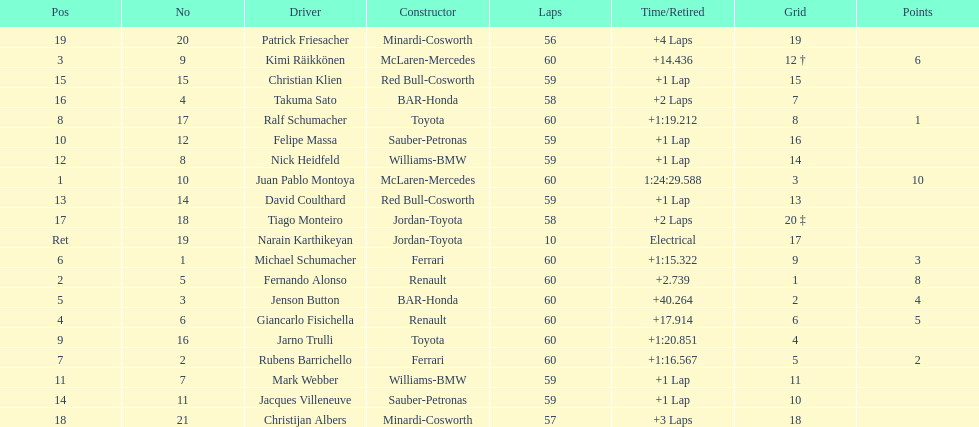Would you be able to parse every entry in this table? {'header': ['Pos', 'No', 'Driver', 'Constructor', 'Laps', 'Time/Retired', 'Grid', 'Points'], 'rows': [['19', '20', 'Patrick Friesacher', 'Minardi-Cosworth', '56', '+4 Laps', '19', ''], ['3', '9', 'Kimi Räikkönen', 'McLaren-Mercedes', '60', '+14.436', '12 †', '6'], ['15', '15', 'Christian Klien', 'Red Bull-Cosworth', '59', '+1 Lap', '15', ''], ['16', '4', 'Takuma Sato', 'BAR-Honda', '58', '+2 Laps', '7', ''], ['8', '17', 'Ralf Schumacher', 'Toyota', '60', '+1:19.212', '8', '1'], ['10', '12', 'Felipe Massa', 'Sauber-Petronas', '59', '+1 Lap', '16', ''], ['12', '8', 'Nick Heidfeld', 'Williams-BMW', '59', '+1 Lap', '14', ''], ['1', '10', 'Juan Pablo Montoya', 'McLaren-Mercedes', '60', '1:24:29.588', '3', '10'], ['13', '14', 'David Coulthard', 'Red Bull-Cosworth', '59', '+1 Lap', '13', ''], ['17', '18', 'Tiago Monteiro', 'Jordan-Toyota', '58', '+2 Laps', '20 ‡', ''], ['Ret', '19', 'Narain Karthikeyan', 'Jordan-Toyota', '10', 'Electrical', '17', ''], ['6', '1', 'Michael Schumacher', 'Ferrari', '60', '+1:15.322', '9', '3'], ['2', '5', 'Fernando Alonso', 'Renault', '60', '+2.739', '1', '8'], ['5', '3', 'Jenson Button', 'BAR-Honda', '60', '+40.264', '2', '4'], ['4', '6', 'Giancarlo Fisichella', 'Renault', '60', '+17.914', '6', '5'], ['9', '16', 'Jarno Trulli', 'Toyota', '60', '+1:20.851', '4', ''], ['7', '2', 'Rubens Barrichello', 'Ferrari', '60', '+1:16.567', '5', '2'], ['11', '7', 'Mark Webber', 'Williams-BMW', '59', '+1 Lap', '11', ''], ['14', '11', 'Jacques Villeneuve', 'Sauber-Petronas', '59', '+1 Lap', '10', ''], ['18', '21', 'Christijan Albers', 'Minardi-Cosworth', '57', '+3 Laps', '18', '']]} How many drivers received points from the race? 8. 